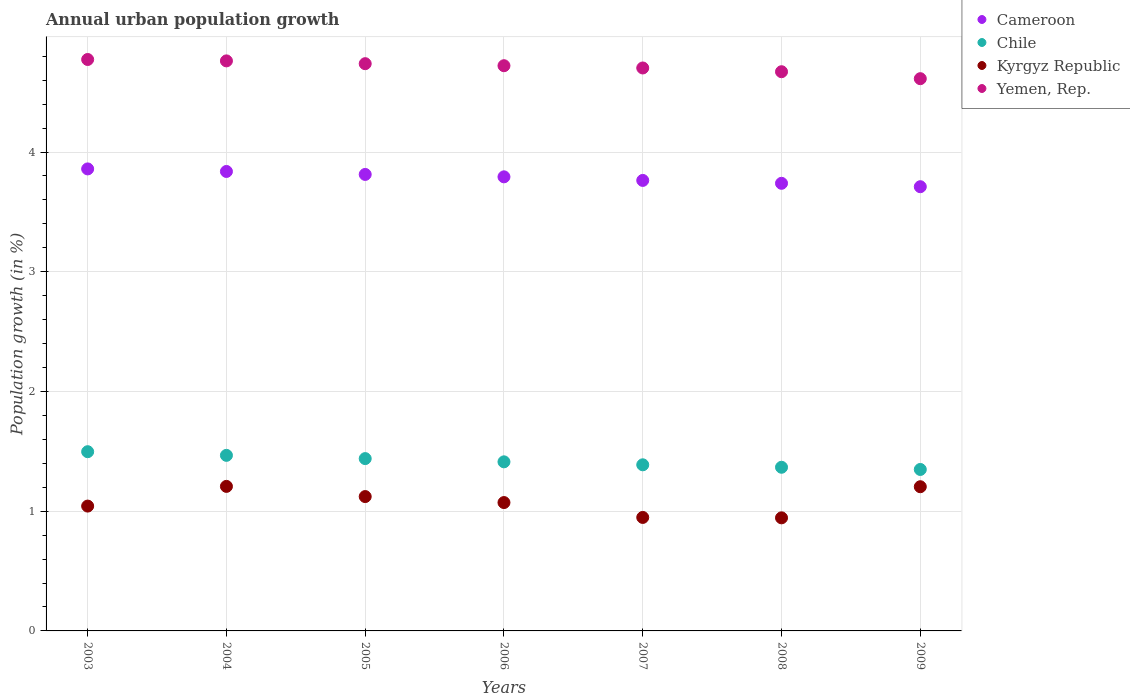How many different coloured dotlines are there?
Ensure brevity in your answer.  4. What is the percentage of urban population growth in Cameroon in 2009?
Offer a terse response. 3.71. Across all years, what is the maximum percentage of urban population growth in Yemen, Rep.?
Your response must be concise. 4.77. Across all years, what is the minimum percentage of urban population growth in Kyrgyz Republic?
Your response must be concise. 0.94. In which year was the percentage of urban population growth in Cameroon maximum?
Keep it short and to the point. 2003. In which year was the percentage of urban population growth in Chile minimum?
Give a very brief answer. 2009. What is the total percentage of urban population growth in Yemen, Rep. in the graph?
Offer a very short reply. 32.98. What is the difference between the percentage of urban population growth in Kyrgyz Republic in 2006 and that in 2009?
Offer a very short reply. -0.13. What is the difference between the percentage of urban population growth in Cameroon in 2006 and the percentage of urban population growth in Kyrgyz Republic in 2008?
Your answer should be compact. 2.85. What is the average percentage of urban population growth in Kyrgyz Republic per year?
Your answer should be very brief. 1.08. In the year 2004, what is the difference between the percentage of urban population growth in Kyrgyz Republic and percentage of urban population growth in Yemen, Rep.?
Your answer should be compact. -3.55. What is the ratio of the percentage of urban population growth in Chile in 2007 to that in 2009?
Offer a very short reply. 1.03. Is the difference between the percentage of urban population growth in Kyrgyz Republic in 2008 and 2009 greater than the difference between the percentage of urban population growth in Yemen, Rep. in 2008 and 2009?
Provide a short and direct response. No. What is the difference between the highest and the second highest percentage of urban population growth in Yemen, Rep.?
Your answer should be compact. 0.01. What is the difference between the highest and the lowest percentage of urban population growth in Chile?
Your response must be concise. 0.15. Is the sum of the percentage of urban population growth in Chile in 2005 and 2009 greater than the maximum percentage of urban population growth in Yemen, Rep. across all years?
Your answer should be very brief. No. Is it the case that in every year, the sum of the percentage of urban population growth in Cameroon and percentage of urban population growth in Chile  is greater than the sum of percentage of urban population growth in Yemen, Rep. and percentage of urban population growth in Kyrgyz Republic?
Ensure brevity in your answer.  No. Is it the case that in every year, the sum of the percentage of urban population growth in Cameroon and percentage of urban population growth in Yemen, Rep.  is greater than the percentage of urban population growth in Chile?
Your answer should be very brief. Yes. Does the percentage of urban population growth in Yemen, Rep. monotonically increase over the years?
Your answer should be very brief. No. Is the percentage of urban population growth in Yemen, Rep. strictly less than the percentage of urban population growth in Cameroon over the years?
Provide a short and direct response. No. How many dotlines are there?
Offer a very short reply. 4. How many years are there in the graph?
Your answer should be compact. 7. Are the values on the major ticks of Y-axis written in scientific E-notation?
Your answer should be compact. No. Where does the legend appear in the graph?
Give a very brief answer. Top right. How many legend labels are there?
Provide a succinct answer. 4. How are the legend labels stacked?
Offer a terse response. Vertical. What is the title of the graph?
Your answer should be very brief. Annual urban population growth. What is the label or title of the Y-axis?
Make the answer very short. Population growth (in %). What is the Population growth (in %) of Cameroon in 2003?
Offer a terse response. 3.86. What is the Population growth (in %) in Chile in 2003?
Keep it short and to the point. 1.5. What is the Population growth (in %) of Kyrgyz Republic in 2003?
Your response must be concise. 1.04. What is the Population growth (in %) in Yemen, Rep. in 2003?
Your answer should be compact. 4.77. What is the Population growth (in %) in Cameroon in 2004?
Offer a very short reply. 3.84. What is the Population growth (in %) of Chile in 2004?
Offer a very short reply. 1.47. What is the Population growth (in %) of Kyrgyz Republic in 2004?
Make the answer very short. 1.21. What is the Population growth (in %) in Yemen, Rep. in 2004?
Your response must be concise. 4.76. What is the Population growth (in %) in Cameroon in 2005?
Make the answer very short. 3.81. What is the Population growth (in %) of Chile in 2005?
Offer a very short reply. 1.44. What is the Population growth (in %) in Kyrgyz Republic in 2005?
Provide a short and direct response. 1.12. What is the Population growth (in %) of Yemen, Rep. in 2005?
Make the answer very short. 4.74. What is the Population growth (in %) of Cameroon in 2006?
Ensure brevity in your answer.  3.79. What is the Population growth (in %) in Chile in 2006?
Ensure brevity in your answer.  1.41. What is the Population growth (in %) in Kyrgyz Republic in 2006?
Provide a short and direct response. 1.07. What is the Population growth (in %) in Yemen, Rep. in 2006?
Keep it short and to the point. 4.72. What is the Population growth (in %) of Cameroon in 2007?
Offer a very short reply. 3.76. What is the Population growth (in %) of Chile in 2007?
Your answer should be very brief. 1.39. What is the Population growth (in %) of Kyrgyz Republic in 2007?
Keep it short and to the point. 0.95. What is the Population growth (in %) in Yemen, Rep. in 2007?
Offer a terse response. 4.7. What is the Population growth (in %) in Cameroon in 2008?
Give a very brief answer. 3.74. What is the Population growth (in %) of Chile in 2008?
Offer a terse response. 1.37. What is the Population growth (in %) in Kyrgyz Republic in 2008?
Ensure brevity in your answer.  0.94. What is the Population growth (in %) in Yemen, Rep. in 2008?
Offer a terse response. 4.67. What is the Population growth (in %) in Cameroon in 2009?
Offer a very short reply. 3.71. What is the Population growth (in %) of Chile in 2009?
Offer a very short reply. 1.35. What is the Population growth (in %) of Kyrgyz Republic in 2009?
Provide a short and direct response. 1.2. What is the Population growth (in %) of Yemen, Rep. in 2009?
Keep it short and to the point. 4.61. Across all years, what is the maximum Population growth (in %) of Cameroon?
Provide a succinct answer. 3.86. Across all years, what is the maximum Population growth (in %) in Chile?
Provide a succinct answer. 1.5. Across all years, what is the maximum Population growth (in %) of Kyrgyz Republic?
Give a very brief answer. 1.21. Across all years, what is the maximum Population growth (in %) of Yemen, Rep.?
Your answer should be compact. 4.77. Across all years, what is the minimum Population growth (in %) in Cameroon?
Your answer should be compact. 3.71. Across all years, what is the minimum Population growth (in %) of Chile?
Provide a succinct answer. 1.35. Across all years, what is the minimum Population growth (in %) in Kyrgyz Republic?
Give a very brief answer. 0.94. Across all years, what is the minimum Population growth (in %) of Yemen, Rep.?
Give a very brief answer. 4.61. What is the total Population growth (in %) of Cameroon in the graph?
Your response must be concise. 26.52. What is the total Population growth (in %) of Chile in the graph?
Your answer should be compact. 9.92. What is the total Population growth (in %) of Kyrgyz Republic in the graph?
Provide a short and direct response. 7.54. What is the total Population growth (in %) of Yemen, Rep. in the graph?
Offer a very short reply. 32.98. What is the difference between the Population growth (in %) in Cameroon in 2003 and that in 2004?
Provide a short and direct response. 0.02. What is the difference between the Population growth (in %) in Chile in 2003 and that in 2004?
Make the answer very short. 0.03. What is the difference between the Population growth (in %) in Kyrgyz Republic in 2003 and that in 2004?
Give a very brief answer. -0.16. What is the difference between the Population growth (in %) of Yemen, Rep. in 2003 and that in 2004?
Provide a short and direct response. 0.01. What is the difference between the Population growth (in %) of Cameroon in 2003 and that in 2005?
Make the answer very short. 0.05. What is the difference between the Population growth (in %) in Chile in 2003 and that in 2005?
Keep it short and to the point. 0.06. What is the difference between the Population growth (in %) in Kyrgyz Republic in 2003 and that in 2005?
Provide a short and direct response. -0.08. What is the difference between the Population growth (in %) in Yemen, Rep. in 2003 and that in 2005?
Ensure brevity in your answer.  0.04. What is the difference between the Population growth (in %) in Cameroon in 2003 and that in 2006?
Offer a very short reply. 0.07. What is the difference between the Population growth (in %) in Chile in 2003 and that in 2006?
Your response must be concise. 0.08. What is the difference between the Population growth (in %) of Kyrgyz Republic in 2003 and that in 2006?
Offer a very short reply. -0.03. What is the difference between the Population growth (in %) of Yemen, Rep. in 2003 and that in 2006?
Your answer should be very brief. 0.05. What is the difference between the Population growth (in %) in Cameroon in 2003 and that in 2007?
Give a very brief answer. 0.1. What is the difference between the Population growth (in %) in Chile in 2003 and that in 2007?
Offer a terse response. 0.11. What is the difference between the Population growth (in %) of Kyrgyz Republic in 2003 and that in 2007?
Your response must be concise. 0.09. What is the difference between the Population growth (in %) of Yemen, Rep. in 2003 and that in 2007?
Your answer should be compact. 0.07. What is the difference between the Population growth (in %) of Cameroon in 2003 and that in 2008?
Make the answer very short. 0.12. What is the difference between the Population growth (in %) in Chile in 2003 and that in 2008?
Offer a very short reply. 0.13. What is the difference between the Population growth (in %) of Kyrgyz Republic in 2003 and that in 2008?
Your response must be concise. 0.1. What is the difference between the Population growth (in %) in Yemen, Rep. in 2003 and that in 2008?
Provide a short and direct response. 0.1. What is the difference between the Population growth (in %) of Cameroon in 2003 and that in 2009?
Your answer should be compact. 0.15. What is the difference between the Population growth (in %) in Chile in 2003 and that in 2009?
Provide a short and direct response. 0.15. What is the difference between the Population growth (in %) of Kyrgyz Republic in 2003 and that in 2009?
Provide a succinct answer. -0.16. What is the difference between the Population growth (in %) of Yemen, Rep. in 2003 and that in 2009?
Your answer should be compact. 0.16. What is the difference between the Population growth (in %) in Cameroon in 2004 and that in 2005?
Keep it short and to the point. 0.02. What is the difference between the Population growth (in %) in Chile in 2004 and that in 2005?
Ensure brevity in your answer.  0.03. What is the difference between the Population growth (in %) of Kyrgyz Republic in 2004 and that in 2005?
Your answer should be compact. 0.09. What is the difference between the Population growth (in %) of Yemen, Rep. in 2004 and that in 2005?
Ensure brevity in your answer.  0.02. What is the difference between the Population growth (in %) in Cameroon in 2004 and that in 2006?
Provide a succinct answer. 0.04. What is the difference between the Population growth (in %) of Chile in 2004 and that in 2006?
Provide a succinct answer. 0.05. What is the difference between the Population growth (in %) of Kyrgyz Republic in 2004 and that in 2006?
Keep it short and to the point. 0.14. What is the difference between the Population growth (in %) in Yemen, Rep. in 2004 and that in 2006?
Ensure brevity in your answer.  0.04. What is the difference between the Population growth (in %) of Cameroon in 2004 and that in 2007?
Offer a very short reply. 0.07. What is the difference between the Population growth (in %) in Chile in 2004 and that in 2007?
Your answer should be very brief. 0.08. What is the difference between the Population growth (in %) of Kyrgyz Republic in 2004 and that in 2007?
Provide a succinct answer. 0.26. What is the difference between the Population growth (in %) of Yemen, Rep. in 2004 and that in 2007?
Offer a terse response. 0.06. What is the difference between the Population growth (in %) in Cameroon in 2004 and that in 2008?
Your response must be concise. 0.1. What is the difference between the Population growth (in %) in Chile in 2004 and that in 2008?
Keep it short and to the point. 0.1. What is the difference between the Population growth (in %) in Kyrgyz Republic in 2004 and that in 2008?
Ensure brevity in your answer.  0.26. What is the difference between the Population growth (in %) of Yemen, Rep. in 2004 and that in 2008?
Offer a very short reply. 0.09. What is the difference between the Population growth (in %) of Cameroon in 2004 and that in 2009?
Offer a very short reply. 0.13. What is the difference between the Population growth (in %) of Chile in 2004 and that in 2009?
Give a very brief answer. 0.12. What is the difference between the Population growth (in %) in Kyrgyz Republic in 2004 and that in 2009?
Offer a terse response. 0. What is the difference between the Population growth (in %) of Yemen, Rep. in 2004 and that in 2009?
Provide a short and direct response. 0.15. What is the difference between the Population growth (in %) in Cameroon in 2005 and that in 2006?
Provide a short and direct response. 0.02. What is the difference between the Population growth (in %) of Chile in 2005 and that in 2006?
Offer a very short reply. 0.03. What is the difference between the Population growth (in %) in Kyrgyz Republic in 2005 and that in 2006?
Make the answer very short. 0.05. What is the difference between the Population growth (in %) of Yemen, Rep. in 2005 and that in 2006?
Your answer should be compact. 0.02. What is the difference between the Population growth (in %) of Chile in 2005 and that in 2007?
Offer a terse response. 0.05. What is the difference between the Population growth (in %) in Kyrgyz Republic in 2005 and that in 2007?
Provide a succinct answer. 0.17. What is the difference between the Population growth (in %) in Yemen, Rep. in 2005 and that in 2007?
Ensure brevity in your answer.  0.04. What is the difference between the Population growth (in %) in Cameroon in 2005 and that in 2008?
Offer a terse response. 0.07. What is the difference between the Population growth (in %) of Chile in 2005 and that in 2008?
Make the answer very short. 0.07. What is the difference between the Population growth (in %) of Kyrgyz Republic in 2005 and that in 2008?
Make the answer very short. 0.18. What is the difference between the Population growth (in %) of Yemen, Rep. in 2005 and that in 2008?
Offer a terse response. 0.07. What is the difference between the Population growth (in %) of Cameroon in 2005 and that in 2009?
Ensure brevity in your answer.  0.1. What is the difference between the Population growth (in %) in Chile in 2005 and that in 2009?
Your answer should be compact. 0.09. What is the difference between the Population growth (in %) in Kyrgyz Republic in 2005 and that in 2009?
Give a very brief answer. -0.08. What is the difference between the Population growth (in %) in Yemen, Rep. in 2005 and that in 2009?
Provide a short and direct response. 0.13. What is the difference between the Population growth (in %) in Cameroon in 2006 and that in 2007?
Provide a succinct answer. 0.03. What is the difference between the Population growth (in %) of Chile in 2006 and that in 2007?
Make the answer very short. 0.02. What is the difference between the Population growth (in %) of Kyrgyz Republic in 2006 and that in 2007?
Your answer should be compact. 0.12. What is the difference between the Population growth (in %) of Yemen, Rep. in 2006 and that in 2007?
Ensure brevity in your answer.  0.02. What is the difference between the Population growth (in %) in Cameroon in 2006 and that in 2008?
Ensure brevity in your answer.  0.05. What is the difference between the Population growth (in %) in Chile in 2006 and that in 2008?
Provide a short and direct response. 0.05. What is the difference between the Population growth (in %) in Kyrgyz Republic in 2006 and that in 2008?
Provide a short and direct response. 0.13. What is the difference between the Population growth (in %) in Yemen, Rep. in 2006 and that in 2008?
Provide a succinct answer. 0.05. What is the difference between the Population growth (in %) in Cameroon in 2006 and that in 2009?
Ensure brevity in your answer.  0.08. What is the difference between the Population growth (in %) in Chile in 2006 and that in 2009?
Your answer should be very brief. 0.06. What is the difference between the Population growth (in %) of Kyrgyz Republic in 2006 and that in 2009?
Your response must be concise. -0.13. What is the difference between the Population growth (in %) in Yemen, Rep. in 2006 and that in 2009?
Make the answer very short. 0.11. What is the difference between the Population growth (in %) of Cameroon in 2007 and that in 2008?
Your response must be concise. 0.02. What is the difference between the Population growth (in %) in Chile in 2007 and that in 2008?
Your answer should be compact. 0.02. What is the difference between the Population growth (in %) of Kyrgyz Republic in 2007 and that in 2008?
Ensure brevity in your answer.  0. What is the difference between the Population growth (in %) in Yemen, Rep. in 2007 and that in 2008?
Your answer should be very brief. 0.03. What is the difference between the Population growth (in %) in Cameroon in 2007 and that in 2009?
Keep it short and to the point. 0.05. What is the difference between the Population growth (in %) of Chile in 2007 and that in 2009?
Make the answer very short. 0.04. What is the difference between the Population growth (in %) of Kyrgyz Republic in 2007 and that in 2009?
Ensure brevity in your answer.  -0.26. What is the difference between the Population growth (in %) in Yemen, Rep. in 2007 and that in 2009?
Keep it short and to the point. 0.09. What is the difference between the Population growth (in %) in Cameroon in 2008 and that in 2009?
Provide a short and direct response. 0.03. What is the difference between the Population growth (in %) in Chile in 2008 and that in 2009?
Your answer should be very brief. 0.02. What is the difference between the Population growth (in %) of Kyrgyz Republic in 2008 and that in 2009?
Ensure brevity in your answer.  -0.26. What is the difference between the Population growth (in %) in Yemen, Rep. in 2008 and that in 2009?
Offer a very short reply. 0.06. What is the difference between the Population growth (in %) of Cameroon in 2003 and the Population growth (in %) of Chile in 2004?
Offer a terse response. 2.39. What is the difference between the Population growth (in %) in Cameroon in 2003 and the Population growth (in %) in Kyrgyz Republic in 2004?
Provide a succinct answer. 2.65. What is the difference between the Population growth (in %) of Cameroon in 2003 and the Population growth (in %) of Yemen, Rep. in 2004?
Your answer should be very brief. -0.9. What is the difference between the Population growth (in %) in Chile in 2003 and the Population growth (in %) in Kyrgyz Republic in 2004?
Your response must be concise. 0.29. What is the difference between the Population growth (in %) in Chile in 2003 and the Population growth (in %) in Yemen, Rep. in 2004?
Your answer should be compact. -3.26. What is the difference between the Population growth (in %) in Kyrgyz Republic in 2003 and the Population growth (in %) in Yemen, Rep. in 2004?
Your answer should be compact. -3.72. What is the difference between the Population growth (in %) of Cameroon in 2003 and the Population growth (in %) of Chile in 2005?
Your answer should be compact. 2.42. What is the difference between the Population growth (in %) of Cameroon in 2003 and the Population growth (in %) of Kyrgyz Republic in 2005?
Your answer should be compact. 2.74. What is the difference between the Population growth (in %) in Cameroon in 2003 and the Population growth (in %) in Yemen, Rep. in 2005?
Your response must be concise. -0.88. What is the difference between the Population growth (in %) in Chile in 2003 and the Population growth (in %) in Kyrgyz Republic in 2005?
Ensure brevity in your answer.  0.37. What is the difference between the Population growth (in %) of Chile in 2003 and the Population growth (in %) of Yemen, Rep. in 2005?
Your answer should be compact. -3.24. What is the difference between the Population growth (in %) of Kyrgyz Republic in 2003 and the Population growth (in %) of Yemen, Rep. in 2005?
Your response must be concise. -3.7. What is the difference between the Population growth (in %) of Cameroon in 2003 and the Population growth (in %) of Chile in 2006?
Ensure brevity in your answer.  2.45. What is the difference between the Population growth (in %) in Cameroon in 2003 and the Population growth (in %) in Kyrgyz Republic in 2006?
Provide a succinct answer. 2.79. What is the difference between the Population growth (in %) of Cameroon in 2003 and the Population growth (in %) of Yemen, Rep. in 2006?
Offer a very short reply. -0.86. What is the difference between the Population growth (in %) of Chile in 2003 and the Population growth (in %) of Kyrgyz Republic in 2006?
Make the answer very short. 0.42. What is the difference between the Population growth (in %) in Chile in 2003 and the Population growth (in %) in Yemen, Rep. in 2006?
Keep it short and to the point. -3.22. What is the difference between the Population growth (in %) in Kyrgyz Republic in 2003 and the Population growth (in %) in Yemen, Rep. in 2006?
Ensure brevity in your answer.  -3.68. What is the difference between the Population growth (in %) in Cameroon in 2003 and the Population growth (in %) in Chile in 2007?
Your response must be concise. 2.47. What is the difference between the Population growth (in %) in Cameroon in 2003 and the Population growth (in %) in Kyrgyz Republic in 2007?
Your answer should be very brief. 2.91. What is the difference between the Population growth (in %) of Cameroon in 2003 and the Population growth (in %) of Yemen, Rep. in 2007?
Your answer should be very brief. -0.84. What is the difference between the Population growth (in %) in Chile in 2003 and the Population growth (in %) in Kyrgyz Republic in 2007?
Your answer should be compact. 0.55. What is the difference between the Population growth (in %) of Chile in 2003 and the Population growth (in %) of Yemen, Rep. in 2007?
Provide a succinct answer. -3.21. What is the difference between the Population growth (in %) in Kyrgyz Republic in 2003 and the Population growth (in %) in Yemen, Rep. in 2007?
Make the answer very short. -3.66. What is the difference between the Population growth (in %) in Cameroon in 2003 and the Population growth (in %) in Chile in 2008?
Ensure brevity in your answer.  2.49. What is the difference between the Population growth (in %) in Cameroon in 2003 and the Population growth (in %) in Kyrgyz Republic in 2008?
Ensure brevity in your answer.  2.91. What is the difference between the Population growth (in %) in Cameroon in 2003 and the Population growth (in %) in Yemen, Rep. in 2008?
Provide a short and direct response. -0.81. What is the difference between the Population growth (in %) of Chile in 2003 and the Population growth (in %) of Kyrgyz Republic in 2008?
Offer a terse response. 0.55. What is the difference between the Population growth (in %) of Chile in 2003 and the Population growth (in %) of Yemen, Rep. in 2008?
Offer a very short reply. -3.17. What is the difference between the Population growth (in %) of Kyrgyz Republic in 2003 and the Population growth (in %) of Yemen, Rep. in 2008?
Make the answer very short. -3.63. What is the difference between the Population growth (in %) of Cameroon in 2003 and the Population growth (in %) of Chile in 2009?
Keep it short and to the point. 2.51. What is the difference between the Population growth (in %) of Cameroon in 2003 and the Population growth (in %) of Kyrgyz Republic in 2009?
Give a very brief answer. 2.65. What is the difference between the Population growth (in %) in Cameroon in 2003 and the Population growth (in %) in Yemen, Rep. in 2009?
Give a very brief answer. -0.75. What is the difference between the Population growth (in %) of Chile in 2003 and the Population growth (in %) of Kyrgyz Republic in 2009?
Your response must be concise. 0.29. What is the difference between the Population growth (in %) of Chile in 2003 and the Population growth (in %) of Yemen, Rep. in 2009?
Your response must be concise. -3.12. What is the difference between the Population growth (in %) in Kyrgyz Republic in 2003 and the Population growth (in %) in Yemen, Rep. in 2009?
Provide a short and direct response. -3.57. What is the difference between the Population growth (in %) of Cameroon in 2004 and the Population growth (in %) of Chile in 2005?
Give a very brief answer. 2.4. What is the difference between the Population growth (in %) in Cameroon in 2004 and the Population growth (in %) in Kyrgyz Republic in 2005?
Your answer should be very brief. 2.72. What is the difference between the Population growth (in %) in Cameroon in 2004 and the Population growth (in %) in Yemen, Rep. in 2005?
Provide a short and direct response. -0.9. What is the difference between the Population growth (in %) of Chile in 2004 and the Population growth (in %) of Kyrgyz Republic in 2005?
Offer a terse response. 0.34. What is the difference between the Population growth (in %) in Chile in 2004 and the Population growth (in %) in Yemen, Rep. in 2005?
Your response must be concise. -3.27. What is the difference between the Population growth (in %) of Kyrgyz Republic in 2004 and the Population growth (in %) of Yemen, Rep. in 2005?
Provide a succinct answer. -3.53. What is the difference between the Population growth (in %) of Cameroon in 2004 and the Population growth (in %) of Chile in 2006?
Offer a very short reply. 2.43. What is the difference between the Population growth (in %) of Cameroon in 2004 and the Population growth (in %) of Kyrgyz Republic in 2006?
Give a very brief answer. 2.77. What is the difference between the Population growth (in %) of Cameroon in 2004 and the Population growth (in %) of Yemen, Rep. in 2006?
Your answer should be compact. -0.88. What is the difference between the Population growth (in %) of Chile in 2004 and the Population growth (in %) of Kyrgyz Republic in 2006?
Your answer should be very brief. 0.39. What is the difference between the Population growth (in %) of Chile in 2004 and the Population growth (in %) of Yemen, Rep. in 2006?
Your answer should be very brief. -3.25. What is the difference between the Population growth (in %) of Kyrgyz Republic in 2004 and the Population growth (in %) of Yemen, Rep. in 2006?
Keep it short and to the point. -3.51. What is the difference between the Population growth (in %) of Cameroon in 2004 and the Population growth (in %) of Chile in 2007?
Offer a very short reply. 2.45. What is the difference between the Population growth (in %) in Cameroon in 2004 and the Population growth (in %) in Kyrgyz Republic in 2007?
Make the answer very short. 2.89. What is the difference between the Population growth (in %) of Cameroon in 2004 and the Population growth (in %) of Yemen, Rep. in 2007?
Provide a short and direct response. -0.86. What is the difference between the Population growth (in %) in Chile in 2004 and the Population growth (in %) in Kyrgyz Republic in 2007?
Your response must be concise. 0.52. What is the difference between the Population growth (in %) in Chile in 2004 and the Population growth (in %) in Yemen, Rep. in 2007?
Your response must be concise. -3.24. What is the difference between the Population growth (in %) of Kyrgyz Republic in 2004 and the Population growth (in %) of Yemen, Rep. in 2007?
Provide a short and direct response. -3.5. What is the difference between the Population growth (in %) in Cameroon in 2004 and the Population growth (in %) in Chile in 2008?
Keep it short and to the point. 2.47. What is the difference between the Population growth (in %) of Cameroon in 2004 and the Population growth (in %) of Kyrgyz Republic in 2008?
Your response must be concise. 2.89. What is the difference between the Population growth (in %) in Cameroon in 2004 and the Population growth (in %) in Yemen, Rep. in 2008?
Make the answer very short. -0.83. What is the difference between the Population growth (in %) of Chile in 2004 and the Population growth (in %) of Kyrgyz Republic in 2008?
Provide a succinct answer. 0.52. What is the difference between the Population growth (in %) of Chile in 2004 and the Population growth (in %) of Yemen, Rep. in 2008?
Offer a terse response. -3.2. What is the difference between the Population growth (in %) in Kyrgyz Republic in 2004 and the Population growth (in %) in Yemen, Rep. in 2008?
Make the answer very short. -3.46. What is the difference between the Population growth (in %) in Cameroon in 2004 and the Population growth (in %) in Chile in 2009?
Make the answer very short. 2.49. What is the difference between the Population growth (in %) of Cameroon in 2004 and the Population growth (in %) of Kyrgyz Republic in 2009?
Offer a terse response. 2.63. What is the difference between the Population growth (in %) of Cameroon in 2004 and the Population growth (in %) of Yemen, Rep. in 2009?
Offer a terse response. -0.78. What is the difference between the Population growth (in %) of Chile in 2004 and the Population growth (in %) of Kyrgyz Republic in 2009?
Provide a short and direct response. 0.26. What is the difference between the Population growth (in %) of Chile in 2004 and the Population growth (in %) of Yemen, Rep. in 2009?
Your response must be concise. -3.15. What is the difference between the Population growth (in %) in Kyrgyz Republic in 2004 and the Population growth (in %) in Yemen, Rep. in 2009?
Offer a terse response. -3.41. What is the difference between the Population growth (in %) in Cameroon in 2005 and the Population growth (in %) in Chile in 2006?
Offer a very short reply. 2.4. What is the difference between the Population growth (in %) of Cameroon in 2005 and the Population growth (in %) of Kyrgyz Republic in 2006?
Give a very brief answer. 2.74. What is the difference between the Population growth (in %) of Cameroon in 2005 and the Population growth (in %) of Yemen, Rep. in 2006?
Your answer should be compact. -0.91. What is the difference between the Population growth (in %) in Chile in 2005 and the Population growth (in %) in Kyrgyz Republic in 2006?
Provide a short and direct response. 0.37. What is the difference between the Population growth (in %) in Chile in 2005 and the Population growth (in %) in Yemen, Rep. in 2006?
Give a very brief answer. -3.28. What is the difference between the Population growth (in %) of Kyrgyz Republic in 2005 and the Population growth (in %) of Yemen, Rep. in 2006?
Your response must be concise. -3.6. What is the difference between the Population growth (in %) in Cameroon in 2005 and the Population growth (in %) in Chile in 2007?
Give a very brief answer. 2.43. What is the difference between the Population growth (in %) in Cameroon in 2005 and the Population growth (in %) in Kyrgyz Republic in 2007?
Make the answer very short. 2.87. What is the difference between the Population growth (in %) of Cameroon in 2005 and the Population growth (in %) of Yemen, Rep. in 2007?
Your answer should be very brief. -0.89. What is the difference between the Population growth (in %) in Chile in 2005 and the Population growth (in %) in Kyrgyz Republic in 2007?
Make the answer very short. 0.49. What is the difference between the Population growth (in %) of Chile in 2005 and the Population growth (in %) of Yemen, Rep. in 2007?
Provide a short and direct response. -3.26. What is the difference between the Population growth (in %) of Kyrgyz Republic in 2005 and the Population growth (in %) of Yemen, Rep. in 2007?
Give a very brief answer. -3.58. What is the difference between the Population growth (in %) in Cameroon in 2005 and the Population growth (in %) in Chile in 2008?
Provide a succinct answer. 2.45. What is the difference between the Population growth (in %) in Cameroon in 2005 and the Population growth (in %) in Kyrgyz Republic in 2008?
Provide a succinct answer. 2.87. What is the difference between the Population growth (in %) in Cameroon in 2005 and the Population growth (in %) in Yemen, Rep. in 2008?
Offer a terse response. -0.86. What is the difference between the Population growth (in %) in Chile in 2005 and the Population growth (in %) in Kyrgyz Republic in 2008?
Provide a succinct answer. 0.49. What is the difference between the Population growth (in %) of Chile in 2005 and the Population growth (in %) of Yemen, Rep. in 2008?
Provide a short and direct response. -3.23. What is the difference between the Population growth (in %) of Kyrgyz Republic in 2005 and the Population growth (in %) of Yemen, Rep. in 2008?
Your response must be concise. -3.55. What is the difference between the Population growth (in %) of Cameroon in 2005 and the Population growth (in %) of Chile in 2009?
Give a very brief answer. 2.46. What is the difference between the Population growth (in %) of Cameroon in 2005 and the Population growth (in %) of Kyrgyz Republic in 2009?
Provide a short and direct response. 2.61. What is the difference between the Population growth (in %) of Cameroon in 2005 and the Population growth (in %) of Yemen, Rep. in 2009?
Make the answer very short. -0.8. What is the difference between the Population growth (in %) of Chile in 2005 and the Population growth (in %) of Kyrgyz Republic in 2009?
Offer a very short reply. 0.23. What is the difference between the Population growth (in %) of Chile in 2005 and the Population growth (in %) of Yemen, Rep. in 2009?
Your response must be concise. -3.17. What is the difference between the Population growth (in %) of Kyrgyz Republic in 2005 and the Population growth (in %) of Yemen, Rep. in 2009?
Give a very brief answer. -3.49. What is the difference between the Population growth (in %) of Cameroon in 2006 and the Population growth (in %) of Chile in 2007?
Ensure brevity in your answer.  2.41. What is the difference between the Population growth (in %) in Cameroon in 2006 and the Population growth (in %) in Kyrgyz Republic in 2007?
Your response must be concise. 2.85. What is the difference between the Population growth (in %) of Cameroon in 2006 and the Population growth (in %) of Yemen, Rep. in 2007?
Make the answer very short. -0.91. What is the difference between the Population growth (in %) in Chile in 2006 and the Population growth (in %) in Kyrgyz Republic in 2007?
Keep it short and to the point. 0.46. What is the difference between the Population growth (in %) of Chile in 2006 and the Population growth (in %) of Yemen, Rep. in 2007?
Keep it short and to the point. -3.29. What is the difference between the Population growth (in %) in Kyrgyz Republic in 2006 and the Population growth (in %) in Yemen, Rep. in 2007?
Your response must be concise. -3.63. What is the difference between the Population growth (in %) of Cameroon in 2006 and the Population growth (in %) of Chile in 2008?
Offer a terse response. 2.43. What is the difference between the Population growth (in %) in Cameroon in 2006 and the Population growth (in %) in Kyrgyz Republic in 2008?
Offer a very short reply. 2.85. What is the difference between the Population growth (in %) of Cameroon in 2006 and the Population growth (in %) of Yemen, Rep. in 2008?
Provide a succinct answer. -0.88. What is the difference between the Population growth (in %) of Chile in 2006 and the Population growth (in %) of Kyrgyz Republic in 2008?
Your response must be concise. 0.47. What is the difference between the Population growth (in %) of Chile in 2006 and the Population growth (in %) of Yemen, Rep. in 2008?
Your response must be concise. -3.26. What is the difference between the Population growth (in %) of Kyrgyz Republic in 2006 and the Population growth (in %) of Yemen, Rep. in 2008?
Your response must be concise. -3.6. What is the difference between the Population growth (in %) in Cameroon in 2006 and the Population growth (in %) in Chile in 2009?
Give a very brief answer. 2.44. What is the difference between the Population growth (in %) in Cameroon in 2006 and the Population growth (in %) in Kyrgyz Republic in 2009?
Offer a very short reply. 2.59. What is the difference between the Population growth (in %) of Cameroon in 2006 and the Population growth (in %) of Yemen, Rep. in 2009?
Give a very brief answer. -0.82. What is the difference between the Population growth (in %) of Chile in 2006 and the Population growth (in %) of Kyrgyz Republic in 2009?
Ensure brevity in your answer.  0.21. What is the difference between the Population growth (in %) of Chile in 2006 and the Population growth (in %) of Yemen, Rep. in 2009?
Your answer should be compact. -3.2. What is the difference between the Population growth (in %) in Kyrgyz Republic in 2006 and the Population growth (in %) in Yemen, Rep. in 2009?
Ensure brevity in your answer.  -3.54. What is the difference between the Population growth (in %) in Cameroon in 2007 and the Population growth (in %) in Chile in 2008?
Your response must be concise. 2.4. What is the difference between the Population growth (in %) of Cameroon in 2007 and the Population growth (in %) of Kyrgyz Republic in 2008?
Give a very brief answer. 2.82. What is the difference between the Population growth (in %) of Cameroon in 2007 and the Population growth (in %) of Yemen, Rep. in 2008?
Give a very brief answer. -0.91. What is the difference between the Population growth (in %) in Chile in 2007 and the Population growth (in %) in Kyrgyz Republic in 2008?
Give a very brief answer. 0.44. What is the difference between the Population growth (in %) in Chile in 2007 and the Population growth (in %) in Yemen, Rep. in 2008?
Give a very brief answer. -3.28. What is the difference between the Population growth (in %) of Kyrgyz Republic in 2007 and the Population growth (in %) of Yemen, Rep. in 2008?
Offer a very short reply. -3.72. What is the difference between the Population growth (in %) in Cameroon in 2007 and the Population growth (in %) in Chile in 2009?
Make the answer very short. 2.41. What is the difference between the Population growth (in %) of Cameroon in 2007 and the Population growth (in %) of Kyrgyz Republic in 2009?
Offer a terse response. 2.56. What is the difference between the Population growth (in %) in Cameroon in 2007 and the Population growth (in %) in Yemen, Rep. in 2009?
Your answer should be very brief. -0.85. What is the difference between the Population growth (in %) of Chile in 2007 and the Population growth (in %) of Kyrgyz Republic in 2009?
Your answer should be very brief. 0.18. What is the difference between the Population growth (in %) in Chile in 2007 and the Population growth (in %) in Yemen, Rep. in 2009?
Provide a short and direct response. -3.23. What is the difference between the Population growth (in %) in Kyrgyz Republic in 2007 and the Population growth (in %) in Yemen, Rep. in 2009?
Your answer should be very brief. -3.66. What is the difference between the Population growth (in %) in Cameroon in 2008 and the Population growth (in %) in Chile in 2009?
Your answer should be very brief. 2.39. What is the difference between the Population growth (in %) of Cameroon in 2008 and the Population growth (in %) of Kyrgyz Republic in 2009?
Make the answer very short. 2.53. What is the difference between the Population growth (in %) in Cameroon in 2008 and the Population growth (in %) in Yemen, Rep. in 2009?
Your response must be concise. -0.87. What is the difference between the Population growth (in %) in Chile in 2008 and the Population growth (in %) in Kyrgyz Republic in 2009?
Give a very brief answer. 0.16. What is the difference between the Population growth (in %) of Chile in 2008 and the Population growth (in %) of Yemen, Rep. in 2009?
Your answer should be compact. -3.25. What is the difference between the Population growth (in %) in Kyrgyz Republic in 2008 and the Population growth (in %) in Yemen, Rep. in 2009?
Provide a short and direct response. -3.67. What is the average Population growth (in %) in Cameroon per year?
Provide a succinct answer. 3.79. What is the average Population growth (in %) in Chile per year?
Offer a terse response. 1.42. What is the average Population growth (in %) in Kyrgyz Republic per year?
Your answer should be compact. 1.08. What is the average Population growth (in %) of Yemen, Rep. per year?
Provide a short and direct response. 4.71. In the year 2003, what is the difference between the Population growth (in %) in Cameroon and Population growth (in %) in Chile?
Offer a very short reply. 2.36. In the year 2003, what is the difference between the Population growth (in %) in Cameroon and Population growth (in %) in Kyrgyz Republic?
Keep it short and to the point. 2.82. In the year 2003, what is the difference between the Population growth (in %) in Cameroon and Population growth (in %) in Yemen, Rep.?
Your answer should be compact. -0.91. In the year 2003, what is the difference between the Population growth (in %) of Chile and Population growth (in %) of Kyrgyz Republic?
Make the answer very short. 0.45. In the year 2003, what is the difference between the Population growth (in %) in Chile and Population growth (in %) in Yemen, Rep.?
Make the answer very short. -3.28. In the year 2003, what is the difference between the Population growth (in %) in Kyrgyz Republic and Population growth (in %) in Yemen, Rep.?
Offer a terse response. -3.73. In the year 2004, what is the difference between the Population growth (in %) of Cameroon and Population growth (in %) of Chile?
Offer a terse response. 2.37. In the year 2004, what is the difference between the Population growth (in %) in Cameroon and Population growth (in %) in Kyrgyz Republic?
Provide a succinct answer. 2.63. In the year 2004, what is the difference between the Population growth (in %) in Cameroon and Population growth (in %) in Yemen, Rep.?
Offer a very short reply. -0.92. In the year 2004, what is the difference between the Population growth (in %) in Chile and Population growth (in %) in Kyrgyz Republic?
Provide a succinct answer. 0.26. In the year 2004, what is the difference between the Population growth (in %) of Chile and Population growth (in %) of Yemen, Rep.?
Your answer should be compact. -3.29. In the year 2004, what is the difference between the Population growth (in %) in Kyrgyz Republic and Population growth (in %) in Yemen, Rep.?
Provide a succinct answer. -3.55. In the year 2005, what is the difference between the Population growth (in %) of Cameroon and Population growth (in %) of Chile?
Your answer should be compact. 2.37. In the year 2005, what is the difference between the Population growth (in %) of Cameroon and Population growth (in %) of Kyrgyz Republic?
Provide a short and direct response. 2.69. In the year 2005, what is the difference between the Population growth (in %) of Cameroon and Population growth (in %) of Yemen, Rep.?
Your answer should be very brief. -0.93. In the year 2005, what is the difference between the Population growth (in %) in Chile and Population growth (in %) in Kyrgyz Republic?
Keep it short and to the point. 0.32. In the year 2005, what is the difference between the Population growth (in %) in Chile and Population growth (in %) in Yemen, Rep.?
Your response must be concise. -3.3. In the year 2005, what is the difference between the Population growth (in %) in Kyrgyz Republic and Population growth (in %) in Yemen, Rep.?
Ensure brevity in your answer.  -3.62. In the year 2006, what is the difference between the Population growth (in %) of Cameroon and Population growth (in %) of Chile?
Offer a terse response. 2.38. In the year 2006, what is the difference between the Population growth (in %) of Cameroon and Population growth (in %) of Kyrgyz Republic?
Your response must be concise. 2.72. In the year 2006, what is the difference between the Population growth (in %) in Cameroon and Population growth (in %) in Yemen, Rep.?
Offer a very short reply. -0.93. In the year 2006, what is the difference between the Population growth (in %) of Chile and Population growth (in %) of Kyrgyz Republic?
Give a very brief answer. 0.34. In the year 2006, what is the difference between the Population growth (in %) in Chile and Population growth (in %) in Yemen, Rep.?
Offer a very short reply. -3.31. In the year 2006, what is the difference between the Population growth (in %) in Kyrgyz Republic and Population growth (in %) in Yemen, Rep.?
Ensure brevity in your answer.  -3.65. In the year 2007, what is the difference between the Population growth (in %) of Cameroon and Population growth (in %) of Chile?
Offer a very short reply. 2.38. In the year 2007, what is the difference between the Population growth (in %) of Cameroon and Population growth (in %) of Kyrgyz Republic?
Your answer should be compact. 2.82. In the year 2007, what is the difference between the Population growth (in %) of Cameroon and Population growth (in %) of Yemen, Rep.?
Provide a short and direct response. -0.94. In the year 2007, what is the difference between the Population growth (in %) in Chile and Population growth (in %) in Kyrgyz Republic?
Ensure brevity in your answer.  0.44. In the year 2007, what is the difference between the Population growth (in %) in Chile and Population growth (in %) in Yemen, Rep.?
Your answer should be compact. -3.31. In the year 2007, what is the difference between the Population growth (in %) of Kyrgyz Republic and Population growth (in %) of Yemen, Rep.?
Ensure brevity in your answer.  -3.75. In the year 2008, what is the difference between the Population growth (in %) in Cameroon and Population growth (in %) in Chile?
Provide a succinct answer. 2.37. In the year 2008, what is the difference between the Population growth (in %) in Cameroon and Population growth (in %) in Kyrgyz Republic?
Your response must be concise. 2.79. In the year 2008, what is the difference between the Population growth (in %) in Cameroon and Population growth (in %) in Yemen, Rep.?
Your answer should be very brief. -0.93. In the year 2008, what is the difference between the Population growth (in %) of Chile and Population growth (in %) of Kyrgyz Republic?
Offer a terse response. 0.42. In the year 2008, what is the difference between the Population growth (in %) in Chile and Population growth (in %) in Yemen, Rep.?
Your response must be concise. -3.3. In the year 2008, what is the difference between the Population growth (in %) of Kyrgyz Republic and Population growth (in %) of Yemen, Rep.?
Your answer should be compact. -3.73. In the year 2009, what is the difference between the Population growth (in %) of Cameroon and Population growth (in %) of Chile?
Keep it short and to the point. 2.36. In the year 2009, what is the difference between the Population growth (in %) of Cameroon and Population growth (in %) of Kyrgyz Republic?
Make the answer very short. 2.51. In the year 2009, what is the difference between the Population growth (in %) of Cameroon and Population growth (in %) of Yemen, Rep.?
Your answer should be very brief. -0.9. In the year 2009, what is the difference between the Population growth (in %) of Chile and Population growth (in %) of Kyrgyz Republic?
Make the answer very short. 0.14. In the year 2009, what is the difference between the Population growth (in %) of Chile and Population growth (in %) of Yemen, Rep.?
Your response must be concise. -3.26. In the year 2009, what is the difference between the Population growth (in %) of Kyrgyz Republic and Population growth (in %) of Yemen, Rep.?
Make the answer very short. -3.41. What is the ratio of the Population growth (in %) in Cameroon in 2003 to that in 2004?
Ensure brevity in your answer.  1.01. What is the ratio of the Population growth (in %) of Chile in 2003 to that in 2004?
Your answer should be compact. 1.02. What is the ratio of the Population growth (in %) in Kyrgyz Republic in 2003 to that in 2004?
Ensure brevity in your answer.  0.86. What is the ratio of the Population growth (in %) in Yemen, Rep. in 2003 to that in 2004?
Ensure brevity in your answer.  1. What is the ratio of the Population growth (in %) in Cameroon in 2003 to that in 2005?
Ensure brevity in your answer.  1.01. What is the ratio of the Population growth (in %) of Chile in 2003 to that in 2005?
Your response must be concise. 1.04. What is the ratio of the Population growth (in %) in Kyrgyz Republic in 2003 to that in 2005?
Your response must be concise. 0.93. What is the ratio of the Population growth (in %) of Yemen, Rep. in 2003 to that in 2005?
Ensure brevity in your answer.  1.01. What is the ratio of the Population growth (in %) in Cameroon in 2003 to that in 2006?
Keep it short and to the point. 1.02. What is the ratio of the Population growth (in %) in Chile in 2003 to that in 2006?
Make the answer very short. 1.06. What is the ratio of the Population growth (in %) in Kyrgyz Republic in 2003 to that in 2006?
Your response must be concise. 0.97. What is the ratio of the Population growth (in %) of Yemen, Rep. in 2003 to that in 2006?
Make the answer very short. 1.01. What is the ratio of the Population growth (in %) of Cameroon in 2003 to that in 2007?
Your response must be concise. 1.03. What is the ratio of the Population growth (in %) in Chile in 2003 to that in 2007?
Provide a short and direct response. 1.08. What is the ratio of the Population growth (in %) in Kyrgyz Republic in 2003 to that in 2007?
Keep it short and to the point. 1.1. What is the ratio of the Population growth (in %) in Yemen, Rep. in 2003 to that in 2007?
Make the answer very short. 1.02. What is the ratio of the Population growth (in %) in Cameroon in 2003 to that in 2008?
Your answer should be very brief. 1.03. What is the ratio of the Population growth (in %) in Chile in 2003 to that in 2008?
Offer a very short reply. 1.1. What is the ratio of the Population growth (in %) of Kyrgyz Republic in 2003 to that in 2008?
Offer a terse response. 1.1. What is the ratio of the Population growth (in %) in Yemen, Rep. in 2003 to that in 2008?
Ensure brevity in your answer.  1.02. What is the ratio of the Population growth (in %) of Cameroon in 2003 to that in 2009?
Your response must be concise. 1.04. What is the ratio of the Population growth (in %) in Chile in 2003 to that in 2009?
Your answer should be compact. 1.11. What is the ratio of the Population growth (in %) in Kyrgyz Republic in 2003 to that in 2009?
Your answer should be very brief. 0.87. What is the ratio of the Population growth (in %) in Yemen, Rep. in 2003 to that in 2009?
Provide a short and direct response. 1.03. What is the ratio of the Population growth (in %) of Cameroon in 2004 to that in 2005?
Make the answer very short. 1.01. What is the ratio of the Population growth (in %) in Chile in 2004 to that in 2005?
Your answer should be very brief. 1.02. What is the ratio of the Population growth (in %) in Kyrgyz Republic in 2004 to that in 2005?
Offer a very short reply. 1.08. What is the ratio of the Population growth (in %) in Yemen, Rep. in 2004 to that in 2005?
Ensure brevity in your answer.  1. What is the ratio of the Population growth (in %) of Cameroon in 2004 to that in 2006?
Make the answer very short. 1.01. What is the ratio of the Population growth (in %) in Chile in 2004 to that in 2006?
Offer a very short reply. 1.04. What is the ratio of the Population growth (in %) in Kyrgyz Republic in 2004 to that in 2006?
Your response must be concise. 1.13. What is the ratio of the Population growth (in %) in Yemen, Rep. in 2004 to that in 2006?
Offer a very short reply. 1.01. What is the ratio of the Population growth (in %) in Cameroon in 2004 to that in 2007?
Your answer should be very brief. 1.02. What is the ratio of the Population growth (in %) in Chile in 2004 to that in 2007?
Keep it short and to the point. 1.06. What is the ratio of the Population growth (in %) in Kyrgyz Republic in 2004 to that in 2007?
Offer a terse response. 1.27. What is the ratio of the Population growth (in %) of Yemen, Rep. in 2004 to that in 2007?
Your response must be concise. 1.01. What is the ratio of the Population growth (in %) in Cameroon in 2004 to that in 2008?
Your response must be concise. 1.03. What is the ratio of the Population growth (in %) of Chile in 2004 to that in 2008?
Your response must be concise. 1.07. What is the ratio of the Population growth (in %) of Kyrgyz Republic in 2004 to that in 2008?
Keep it short and to the point. 1.28. What is the ratio of the Population growth (in %) of Yemen, Rep. in 2004 to that in 2008?
Give a very brief answer. 1.02. What is the ratio of the Population growth (in %) of Cameroon in 2004 to that in 2009?
Provide a short and direct response. 1.03. What is the ratio of the Population growth (in %) in Chile in 2004 to that in 2009?
Give a very brief answer. 1.09. What is the ratio of the Population growth (in %) in Yemen, Rep. in 2004 to that in 2009?
Offer a very short reply. 1.03. What is the ratio of the Population growth (in %) of Cameroon in 2005 to that in 2006?
Give a very brief answer. 1.01. What is the ratio of the Population growth (in %) of Chile in 2005 to that in 2006?
Offer a terse response. 1.02. What is the ratio of the Population growth (in %) of Kyrgyz Republic in 2005 to that in 2006?
Your response must be concise. 1.05. What is the ratio of the Population growth (in %) of Yemen, Rep. in 2005 to that in 2006?
Provide a succinct answer. 1. What is the ratio of the Population growth (in %) of Cameroon in 2005 to that in 2007?
Your answer should be compact. 1.01. What is the ratio of the Population growth (in %) of Chile in 2005 to that in 2007?
Your answer should be very brief. 1.04. What is the ratio of the Population growth (in %) of Kyrgyz Republic in 2005 to that in 2007?
Provide a short and direct response. 1.18. What is the ratio of the Population growth (in %) in Yemen, Rep. in 2005 to that in 2007?
Offer a very short reply. 1.01. What is the ratio of the Population growth (in %) in Cameroon in 2005 to that in 2008?
Provide a succinct answer. 1.02. What is the ratio of the Population growth (in %) of Chile in 2005 to that in 2008?
Your response must be concise. 1.05. What is the ratio of the Population growth (in %) in Kyrgyz Republic in 2005 to that in 2008?
Your answer should be very brief. 1.19. What is the ratio of the Population growth (in %) of Yemen, Rep. in 2005 to that in 2008?
Make the answer very short. 1.01. What is the ratio of the Population growth (in %) of Cameroon in 2005 to that in 2009?
Provide a short and direct response. 1.03. What is the ratio of the Population growth (in %) in Chile in 2005 to that in 2009?
Offer a terse response. 1.07. What is the ratio of the Population growth (in %) of Kyrgyz Republic in 2005 to that in 2009?
Your answer should be compact. 0.93. What is the ratio of the Population growth (in %) in Yemen, Rep. in 2005 to that in 2009?
Provide a short and direct response. 1.03. What is the ratio of the Population growth (in %) in Cameroon in 2006 to that in 2007?
Your answer should be compact. 1.01. What is the ratio of the Population growth (in %) of Chile in 2006 to that in 2007?
Give a very brief answer. 1.02. What is the ratio of the Population growth (in %) in Kyrgyz Republic in 2006 to that in 2007?
Make the answer very short. 1.13. What is the ratio of the Population growth (in %) in Yemen, Rep. in 2006 to that in 2007?
Provide a short and direct response. 1. What is the ratio of the Population growth (in %) in Cameroon in 2006 to that in 2008?
Provide a short and direct response. 1.01. What is the ratio of the Population growth (in %) of Chile in 2006 to that in 2008?
Your answer should be compact. 1.03. What is the ratio of the Population growth (in %) of Kyrgyz Republic in 2006 to that in 2008?
Ensure brevity in your answer.  1.14. What is the ratio of the Population growth (in %) of Yemen, Rep. in 2006 to that in 2008?
Offer a terse response. 1.01. What is the ratio of the Population growth (in %) of Cameroon in 2006 to that in 2009?
Provide a short and direct response. 1.02. What is the ratio of the Population growth (in %) in Chile in 2006 to that in 2009?
Keep it short and to the point. 1.05. What is the ratio of the Population growth (in %) of Kyrgyz Republic in 2006 to that in 2009?
Your answer should be very brief. 0.89. What is the ratio of the Population growth (in %) of Yemen, Rep. in 2006 to that in 2009?
Provide a short and direct response. 1.02. What is the ratio of the Population growth (in %) of Chile in 2007 to that in 2008?
Your answer should be compact. 1.01. What is the ratio of the Population growth (in %) of Yemen, Rep. in 2007 to that in 2008?
Offer a very short reply. 1.01. What is the ratio of the Population growth (in %) of Cameroon in 2007 to that in 2009?
Make the answer very short. 1.01. What is the ratio of the Population growth (in %) of Chile in 2007 to that in 2009?
Give a very brief answer. 1.03. What is the ratio of the Population growth (in %) of Kyrgyz Republic in 2007 to that in 2009?
Make the answer very short. 0.79. What is the ratio of the Population growth (in %) of Yemen, Rep. in 2007 to that in 2009?
Provide a short and direct response. 1.02. What is the ratio of the Population growth (in %) in Cameroon in 2008 to that in 2009?
Your answer should be compact. 1.01. What is the ratio of the Population growth (in %) of Chile in 2008 to that in 2009?
Ensure brevity in your answer.  1.01. What is the ratio of the Population growth (in %) in Kyrgyz Republic in 2008 to that in 2009?
Make the answer very short. 0.78. What is the ratio of the Population growth (in %) of Yemen, Rep. in 2008 to that in 2009?
Give a very brief answer. 1.01. What is the difference between the highest and the second highest Population growth (in %) in Cameroon?
Make the answer very short. 0.02. What is the difference between the highest and the second highest Population growth (in %) of Chile?
Your answer should be very brief. 0.03. What is the difference between the highest and the second highest Population growth (in %) in Kyrgyz Republic?
Make the answer very short. 0. What is the difference between the highest and the second highest Population growth (in %) of Yemen, Rep.?
Offer a terse response. 0.01. What is the difference between the highest and the lowest Population growth (in %) of Cameroon?
Your answer should be compact. 0.15. What is the difference between the highest and the lowest Population growth (in %) of Chile?
Keep it short and to the point. 0.15. What is the difference between the highest and the lowest Population growth (in %) in Kyrgyz Republic?
Make the answer very short. 0.26. What is the difference between the highest and the lowest Population growth (in %) of Yemen, Rep.?
Ensure brevity in your answer.  0.16. 